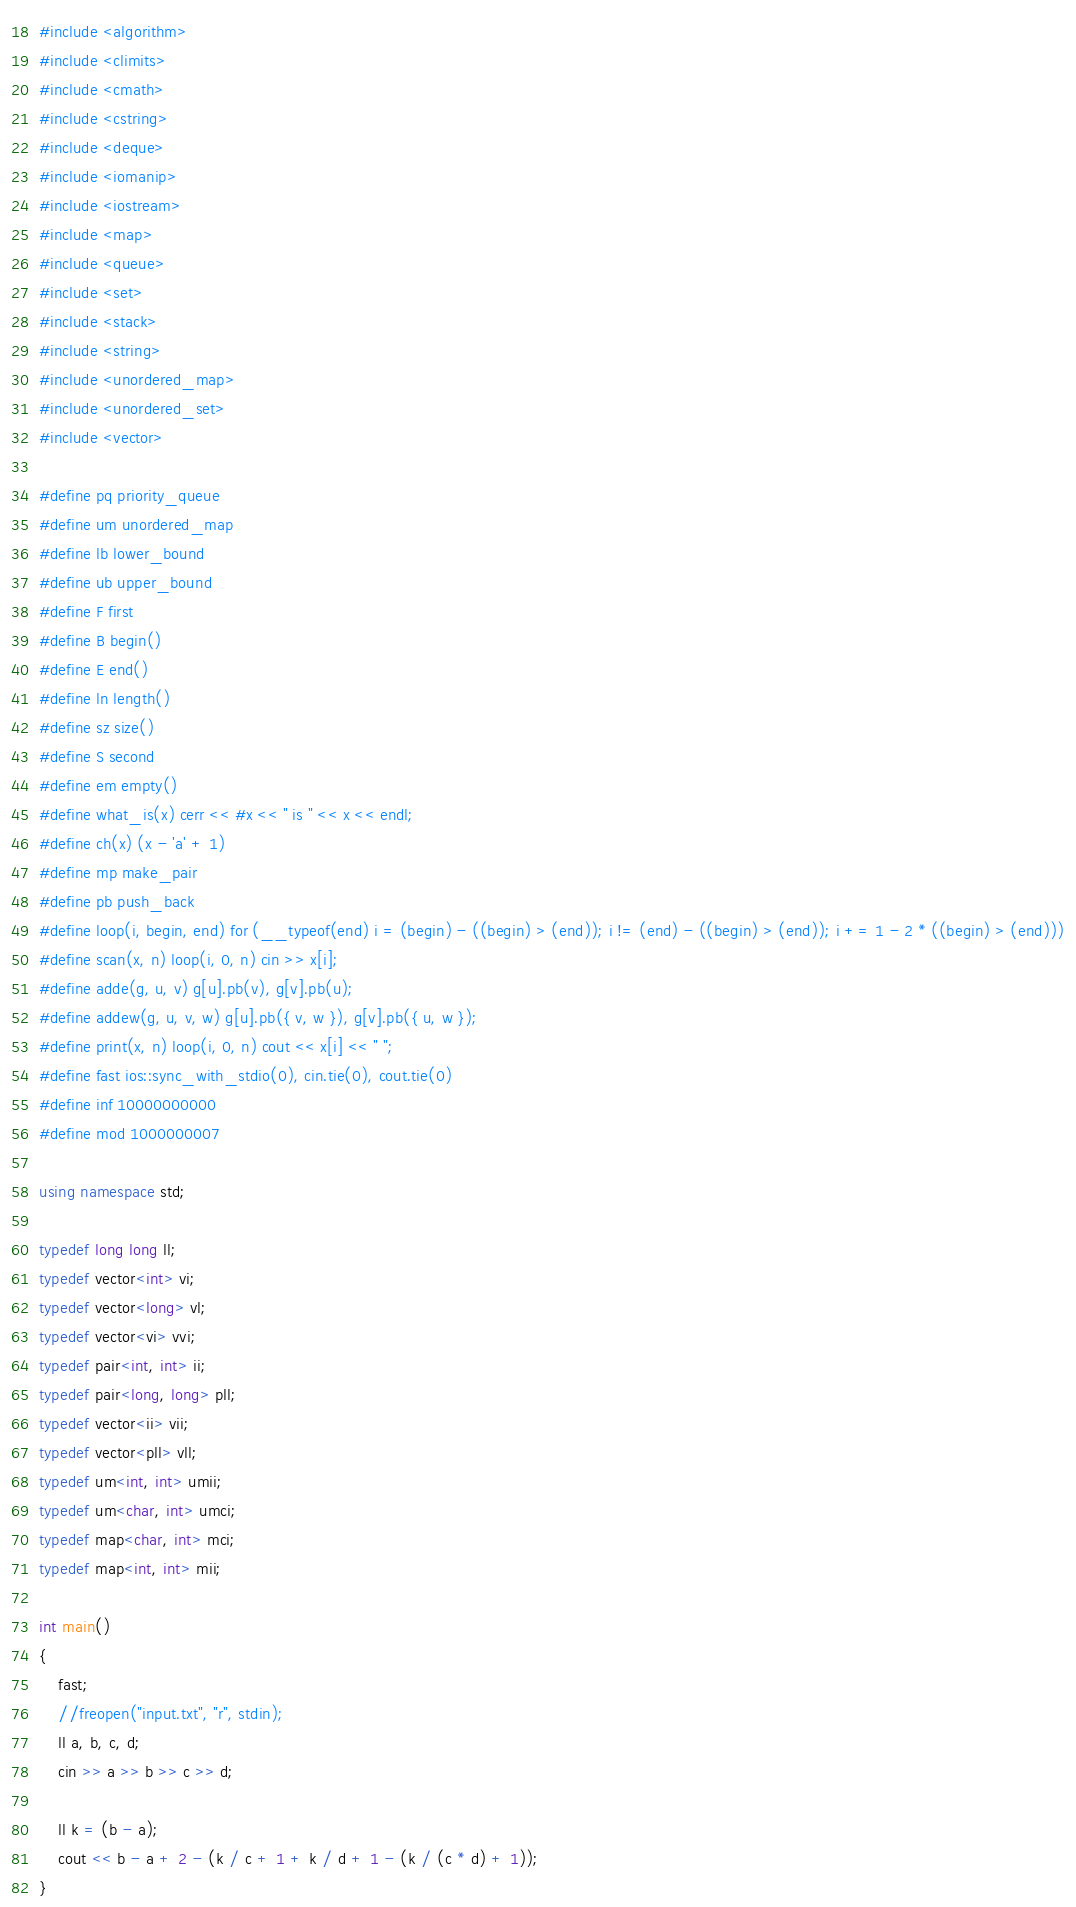<code> <loc_0><loc_0><loc_500><loc_500><_C++_>#include <algorithm>
#include <climits>
#include <cmath>
#include <cstring>
#include <deque>
#include <iomanip>
#include <iostream>
#include <map>
#include <queue>
#include <set>
#include <stack>
#include <string>
#include <unordered_map>
#include <unordered_set>
#include <vector>

#define pq priority_queue
#define um unordered_map
#define lb lower_bound
#define ub upper_bound
#define F first
#define B begin()
#define E end()
#define ln length()
#define sz size()
#define S second
#define em empty()
#define what_is(x) cerr << #x << " is " << x << endl;
#define ch(x) (x - 'a' + 1)
#define mp make_pair
#define pb push_back
#define loop(i, begin, end) for (__typeof(end) i = (begin) - ((begin) > (end)); i != (end) - ((begin) > (end)); i += 1 - 2 * ((begin) > (end)))
#define scan(x, n) loop(i, 0, n) cin >> x[i];
#define adde(g, u, v) g[u].pb(v), g[v].pb(u);
#define addew(g, u, v, w) g[u].pb({ v, w }), g[v].pb({ u, w });
#define print(x, n) loop(i, 0, n) cout << x[i] << " ";
#define fast ios::sync_with_stdio(0), cin.tie(0), cout.tie(0)
#define inf 10000000000
#define mod 1000000007

using namespace std;

typedef long long ll;
typedef vector<int> vi;
typedef vector<long> vl;
typedef vector<vi> vvi;
typedef pair<int, int> ii;
typedef pair<long, long> pll;
typedef vector<ii> vii;
typedef vector<pll> vll;
typedef um<int, int> umii;
typedef um<char, int> umci;
typedef map<char, int> mci;
typedef map<int, int> mii;

int main()
{
    fast;
    //freopen("input.txt", "r", stdin);
    ll a, b, c, d;
    cin >> a >> b >> c >> d;

    ll k = (b - a);
    cout << b - a + 2 - (k / c + 1 + k / d + 1 - (k / (c * d) + 1));
}
</code> 